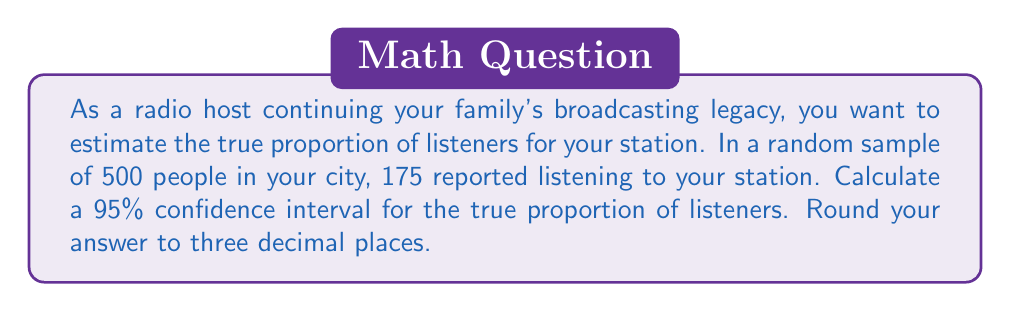What is the answer to this math problem? Let's approach this step-by-step:

1) First, we need to identify the key components:
   - Sample size: $n = 500$
   - Number of successes (listeners): $X = 175$
   - Confidence level: 95% (corresponding to $z = 1.96$)

2) Calculate the sample proportion:
   $\hat{p} = \frac{X}{n} = \frac{175}{500} = 0.35$

3) The formula for the confidence interval is:
   $$\hat{p} \pm z\sqrt{\frac{\hat{p}(1-\hat{p})}{n}}$$

4) Calculate the standard error:
   $$SE = \sqrt{\frac{\hat{p}(1-\hat{p})}{n}} = \sqrt{\frac{0.35(1-0.35)}{500}} = \sqrt{\frac{0.2275}{500}} = 0.0213$$

5) Calculate the margin of error:
   $$ME = z \times SE = 1.96 \times 0.0213 = 0.0418$$

6) Calculate the confidence interval:
   Lower bound: $0.35 - 0.0418 = 0.3082$
   Upper bound: $0.35 + 0.0418 = 0.3918$

7) Rounding to three decimal places:
   (0.308, 0.392)

Therefore, we can say with 95% confidence that the true proportion of listeners for your radio station is between 0.308 and 0.392, or 30.8% to 39.2%.
Answer: (0.308, 0.392) 